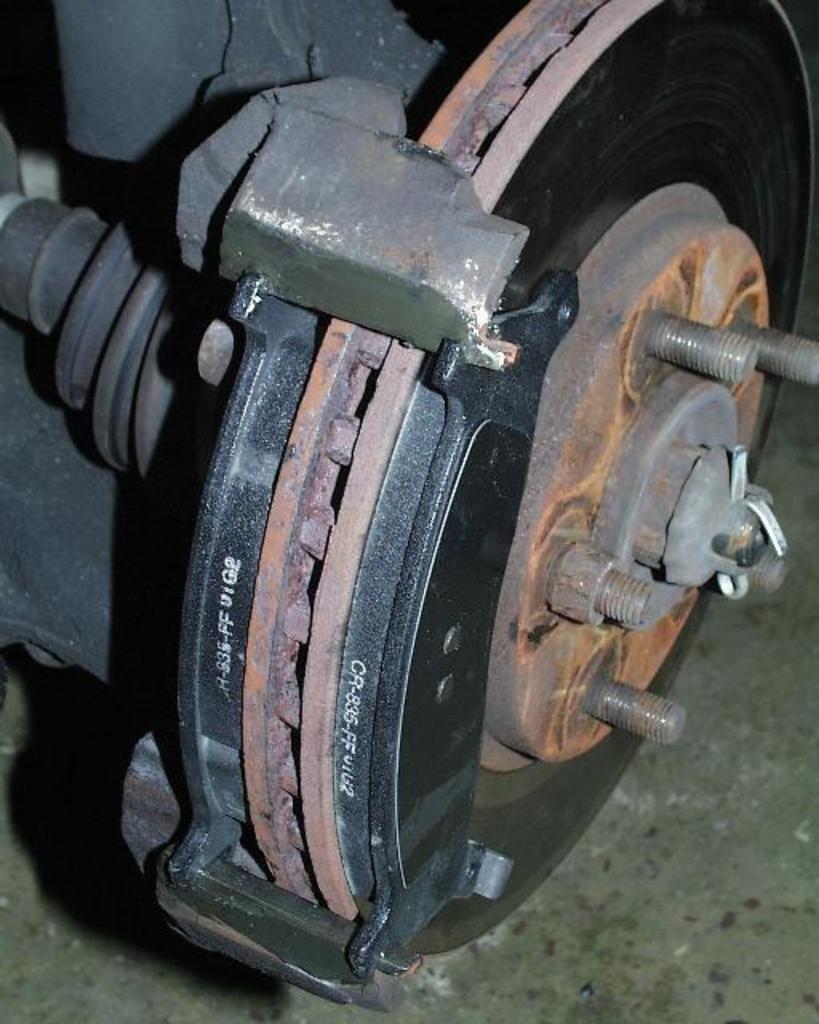Please provide a concise description of this image. In this image I can see a metal object which is placed on the floor. This is looking like a part of vehicle. 